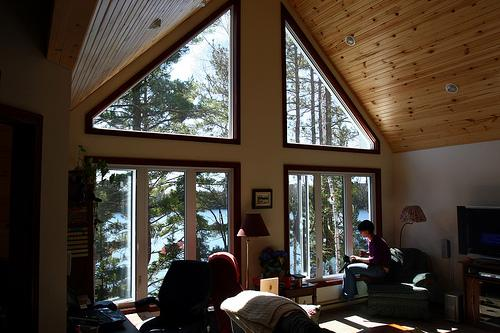What can be seen outside the living room windows? Trees are visible outside of the large living room windows. What are the two different seating options present in the living room? The two seating options available in the room are an armchair and a dark green dotted sofa chair. In the image, what position is the person captured in and where are they sitting? The person appears to be sitting on the arm of a chair near the window in the living room. How many windows are there in the living room and what are their shapes? There are two large windows in the living room, one is triangular-shaped on the left and the other also triangular on the right. Describe the items hanging on the wall and their positions relative to each other. A small framed print is on the wall near a picture, with the print slightly lower than the picture. A speaker is also attached to the wall beneath a light in the ceiling. What are some of the objects that might be useful for entertainment purposes in the living room? A flat screen television, a set of speakers, and a black office chair for comfortable seating. Identify the type of room in the image and mention any specific architectural features it has. The image shows a living room with large windows, wooden-paneled ceiling, and vaulted ceiling design. How many types of plants can be found in the living room and where are they located? There are two types of plants in the living room; one is a green house plant located near the window and the other is a green plant on top of a shelf. Can you provide a brief description of the lamps present in the living room? There is a floor lamp with a reddish-brown shade, another floor lamp with a patterned shade, and a tall lamp against the wall with a burgundy lampshade. State the color and type of blanket found in the living room and where it is located. A beige folded blanket can be seen in the living room, placed on the back of a chair. 